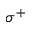Convert formula to latex. <formula><loc_0><loc_0><loc_500><loc_500>\sigma ^ { + }</formula> 